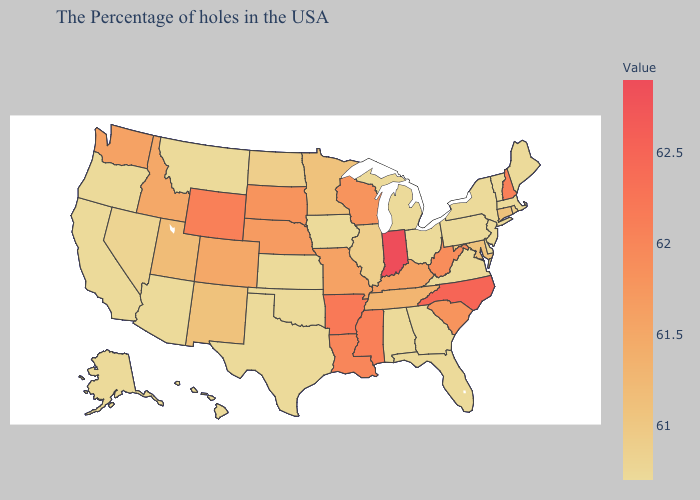Does Oklahoma have the lowest value in the South?
Give a very brief answer. Yes. Does Louisiana have a lower value than Indiana?
Quick response, please. Yes. Does the map have missing data?
Keep it brief. No. Among the states that border New York , does New Jersey have the highest value?
Short answer required. No. Which states hav the highest value in the West?
Be succinct. Wyoming. Which states have the highest value in the USA?
Quick response, please. Indiana. Does Arkansas have the highest value in the South?
Short answer required. No. Which states have the highest value in the USA?
Concise answer only. Indiana. 